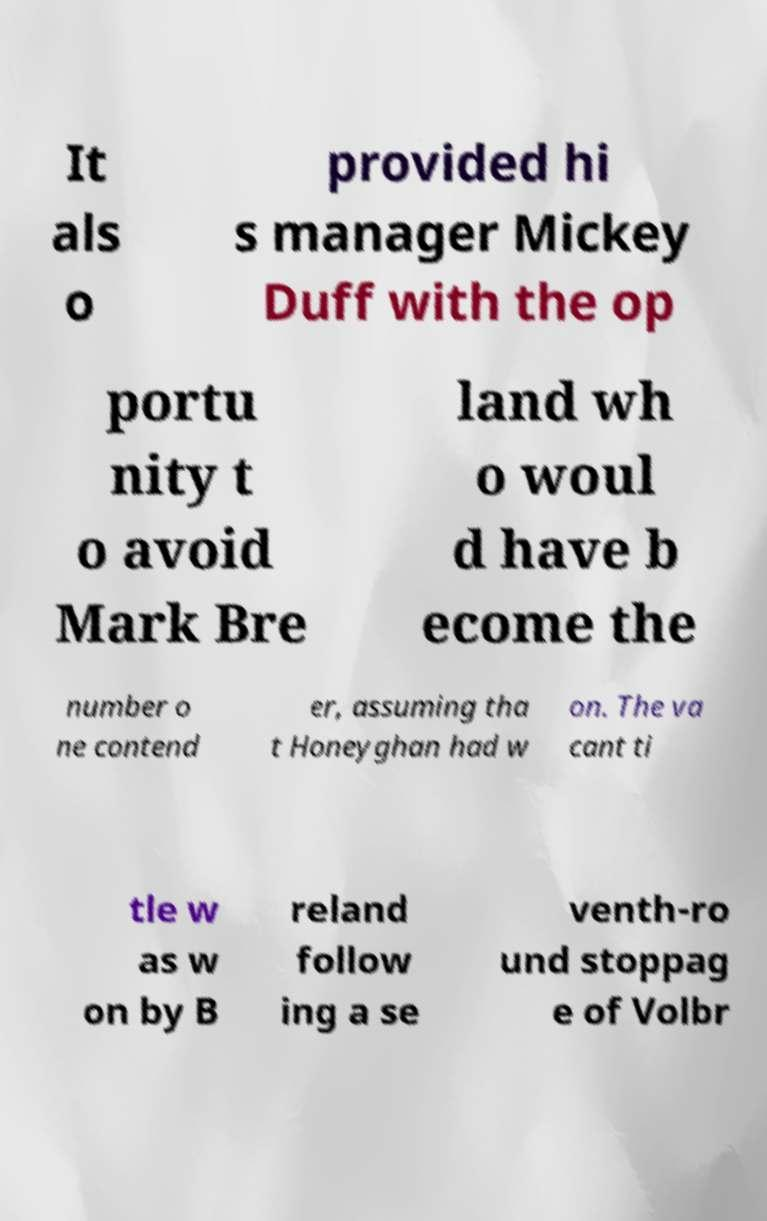Please identify and transcribe the text found in this image. It als o provided hi s manager Mickey Duff with the op portu nity t o avoid Mark Bre land wh o woul d have b ecome the number o ne contend er, assuming tha t Honeyghan had w on. The va cant ti tle w as w on by B reland follow ing a se venth-ro und stoppag e of Volbr 